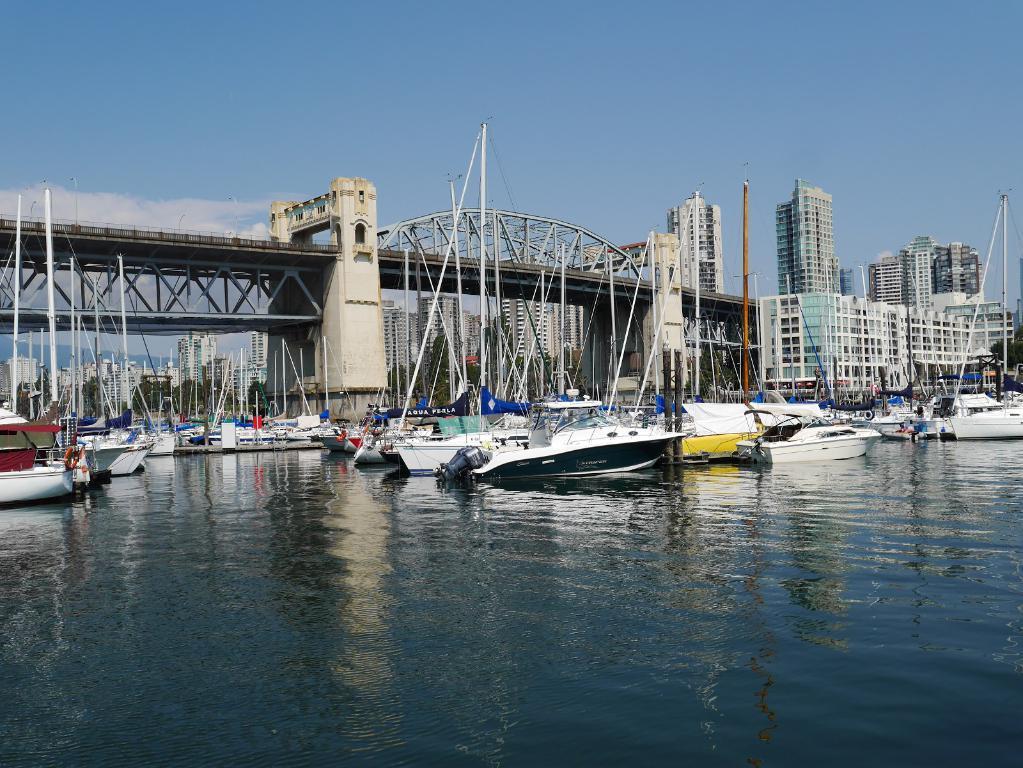Describe this image in one or two sentences. On the down side this is water, there are boats in this water and this is a bridge. There are very big buildings on the right side of an image. 